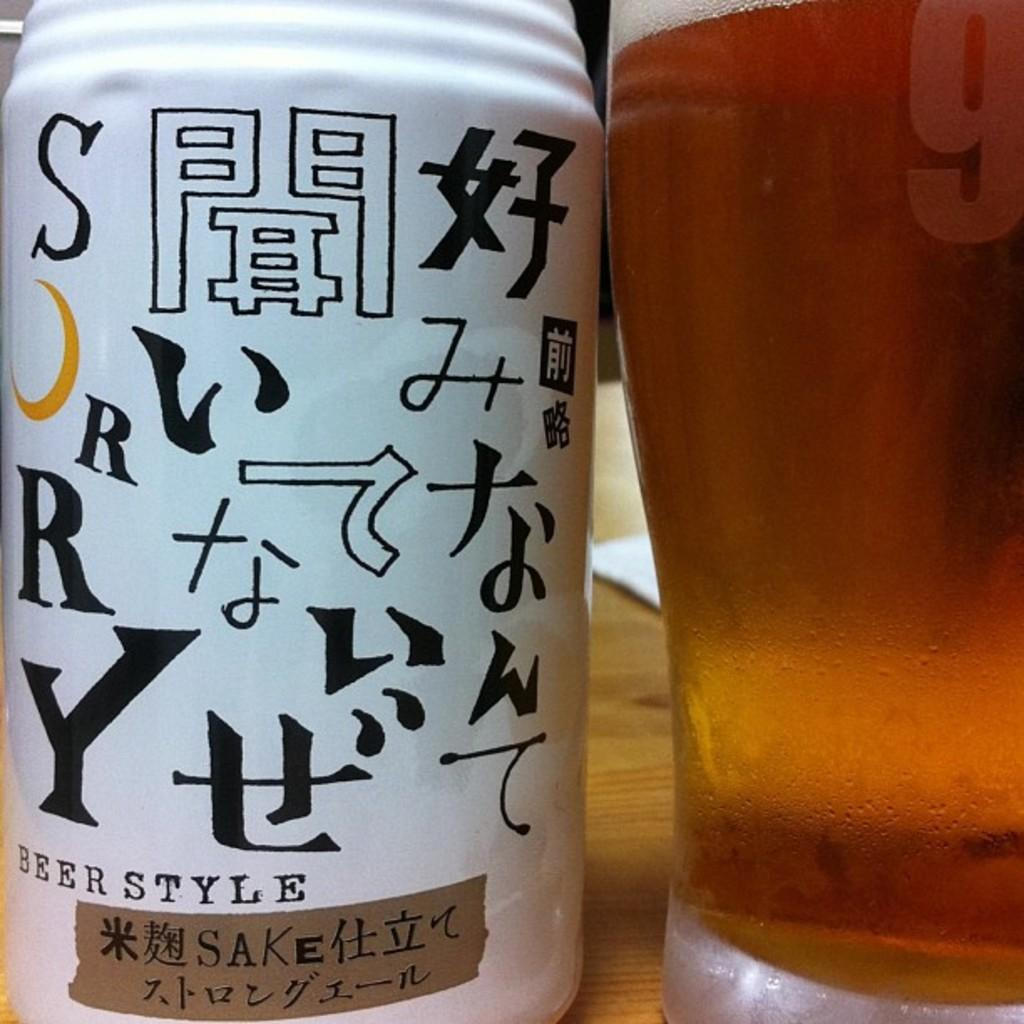Provide a one-sentence caption for the provided image. A can of Beer Style Sake sits on a table. 